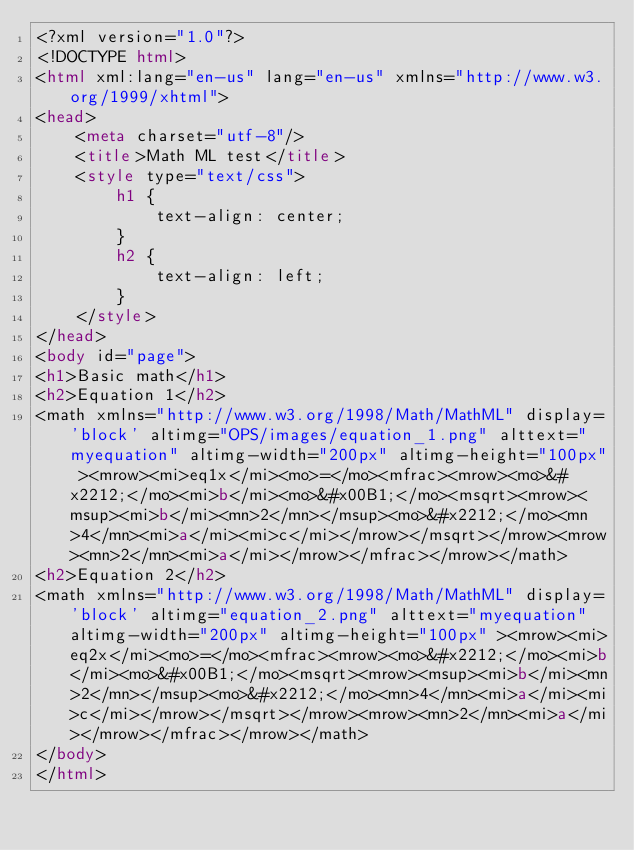<code> <loc_0><loc_0><loc_500><loc_500><_HTML_><?xml version="1.0"?>
<!DOCTYPE html>
<html xml:lang="en-us" lang="en-us" xmlns="http://www.w3.org/1999/xhtml">
<head>
    <meta charset="utf-8"/>
    <title>Math ML test</title>
    <style type="text/css">
        h1 {
            text-align: center;
        }
        h2 {
            text-align: left;
        }
    </style>
</head>
<body id="page">
<h1>Basic math</h1>
<h2>Equation 1</h2>
<math xmlns="http://www.w3.org/1998/Math/MathML" display='block' altimg="OPS/images/equation_1.png" alttext="myequation" altimg-width="200px" altimg-height="100px" ><mrow><mi>eq1x</mi><mo>=</mo><mfrac><mrow><mo>&#x2212;</mo><mi>b</mi><mo>&#x00B1;</mo><msqrt><mrow><msup><mi>b</mi><mn>2</mn></msup><mo>&#x2212;</mo><mn>4</mn><mi>a</mi><mi>c</mi></mrow></msqrt></mrow><mrow><mn>2</mn><mi>a</mi></mrow></mfrac></mrow></math>
<h2>Equation 2</h2>
<math xmlns="http://www.w3.org/1998/Math/MathML" display='block' altimg="equation_2.png" alttext="myequation" altimg-width="200px" altimg-height="100px" ><mrow><mi>eq2x</mi><mo>=</mo><mfrac><mrow><mo>&#x2212;</mo><mi>b</mi><mo>&#x00B1;</mo><msqrt><mrow><msup><mi>b</mi><mn>2</mn></msup><mo>&#x2212;</mo><mn>4</mn><mi>a</mi><mi>c</mi></mrow></msqrt></mrow><mrow><mn>2</mn><mi>a</mi></mrow></mfrac></mrow></math>
</body>
</html>
</code> 